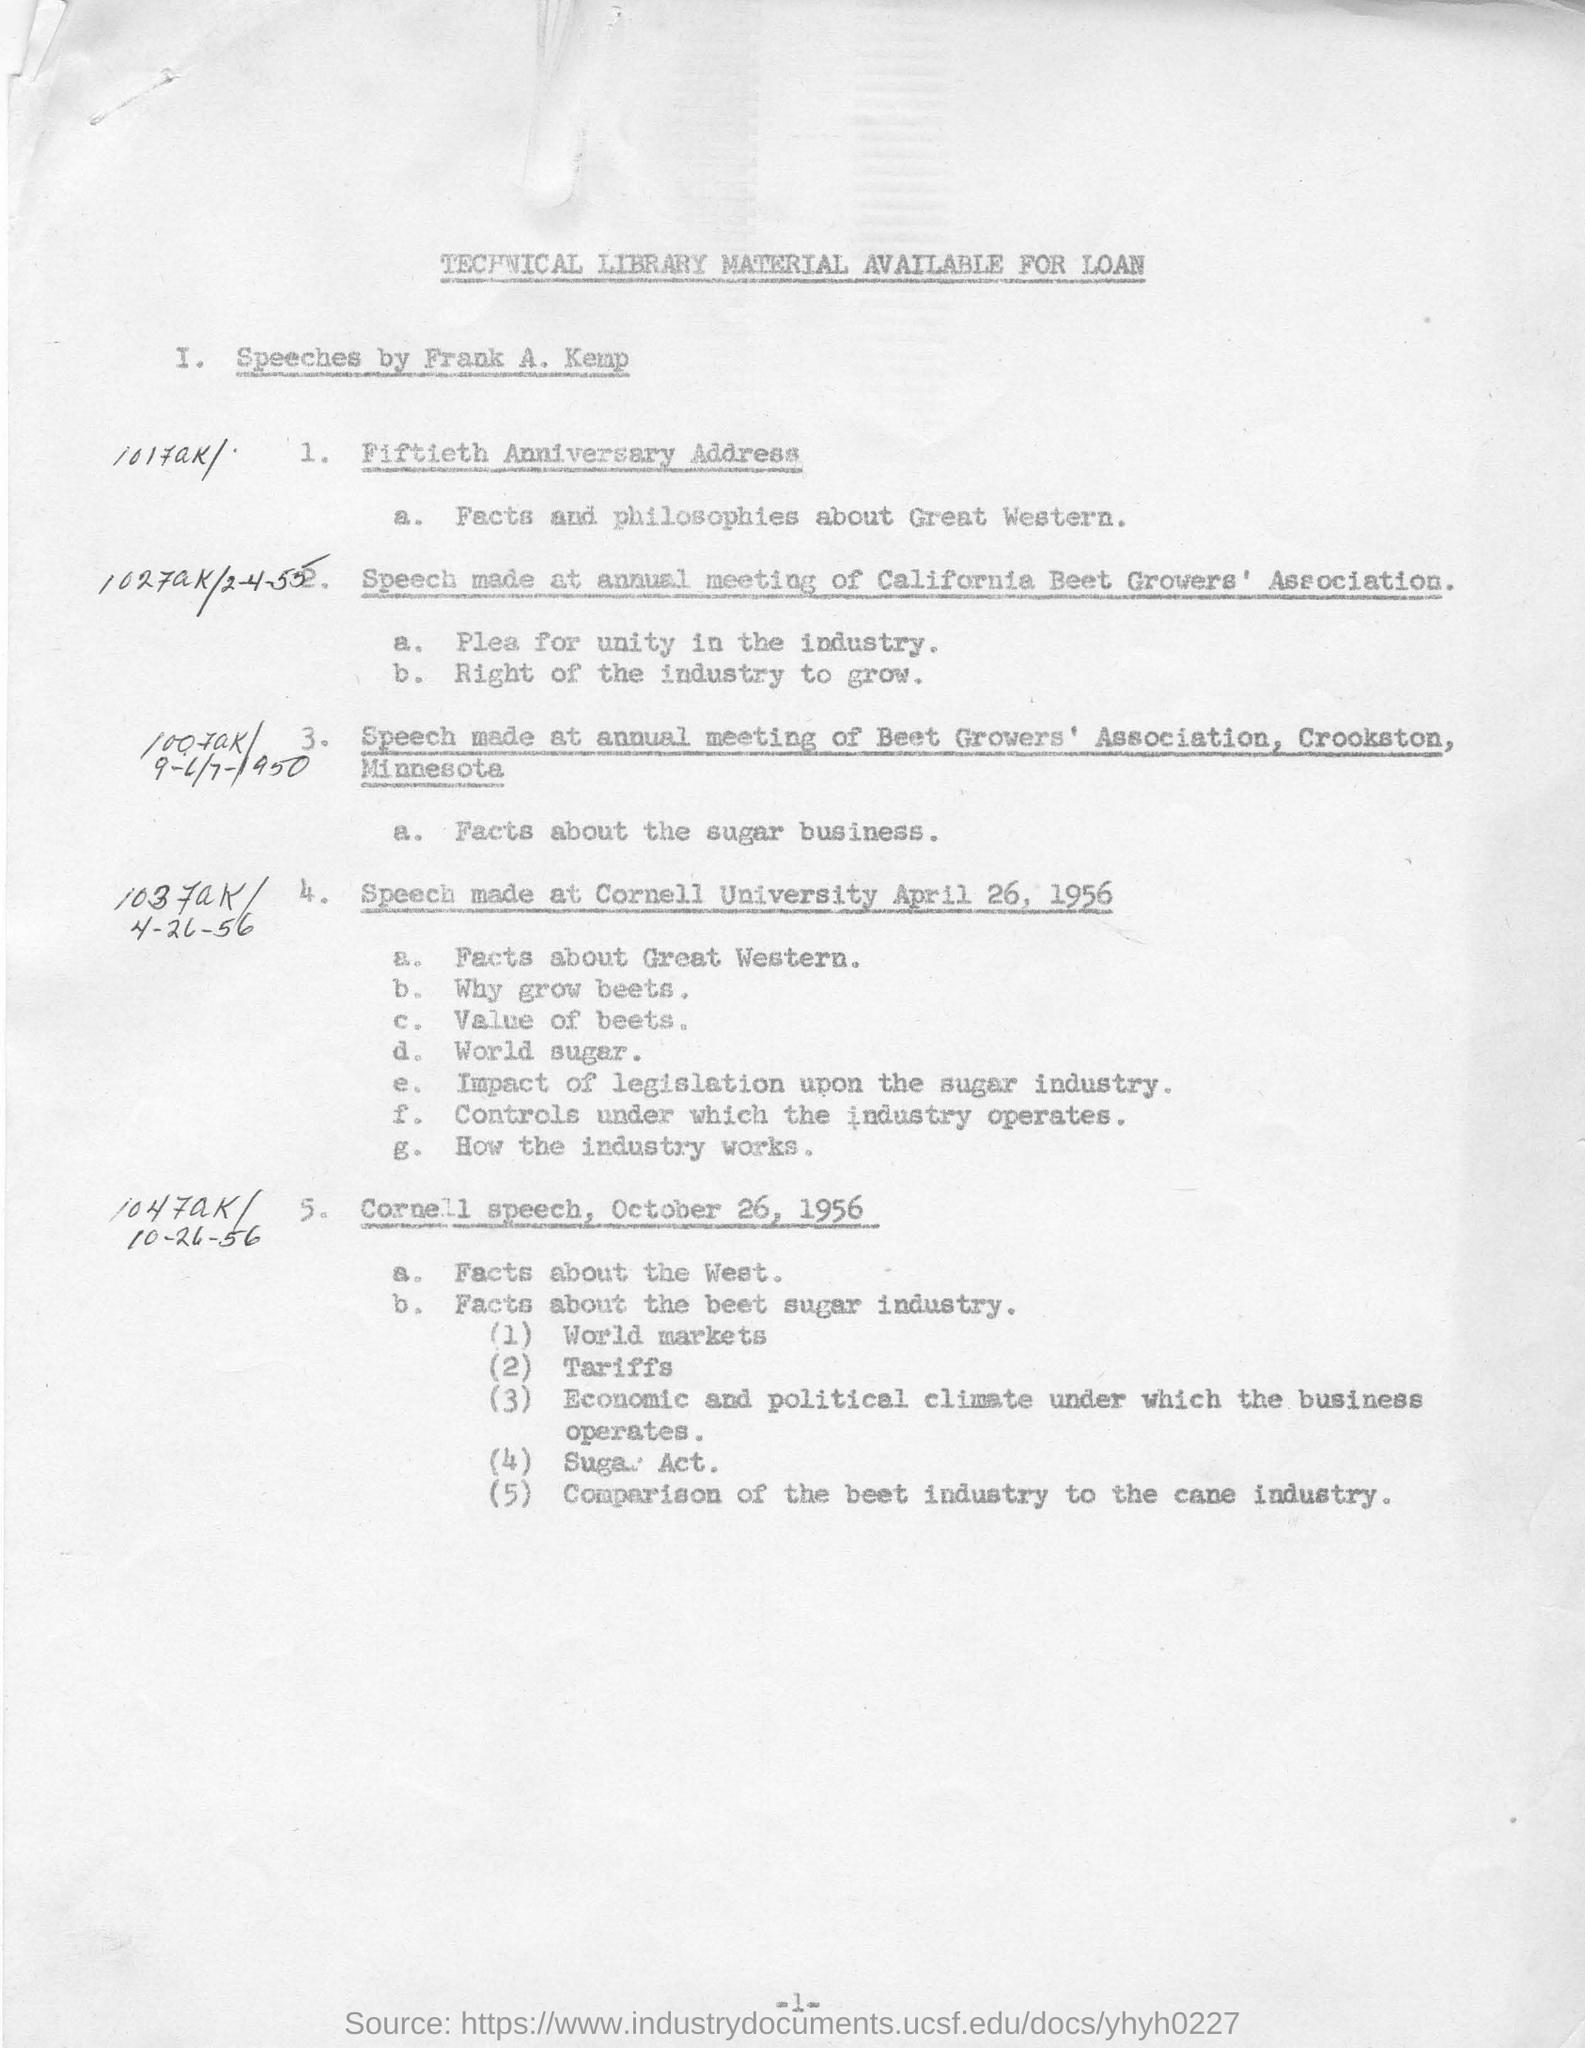When was the 1st cornell university speech held?
Provide a short and direct response. April 26, 1956. What is the main fact  discussed in fiftieth anniversary address?
Your answer should be compact. Facts and philosophies about great western. In which speech the comparison of best cane industry was discussed?
Keep it short and to the point. Cornell speech, October 26, 1956. Name the act came in october speech?
Give a very brief answer. Sugar act. 